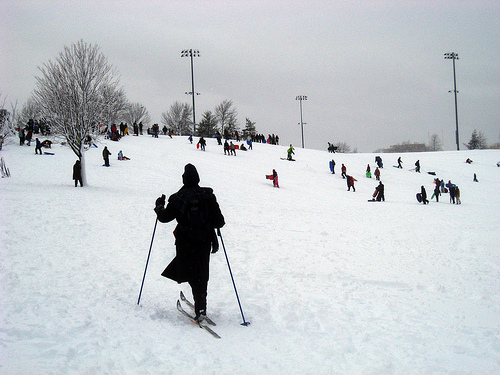Please provide a short description for this region: [0.34, 0.69, 0.45, 0.82]. A neatly arranged pair of skis, ready for an exhilarating ride down the slope. 